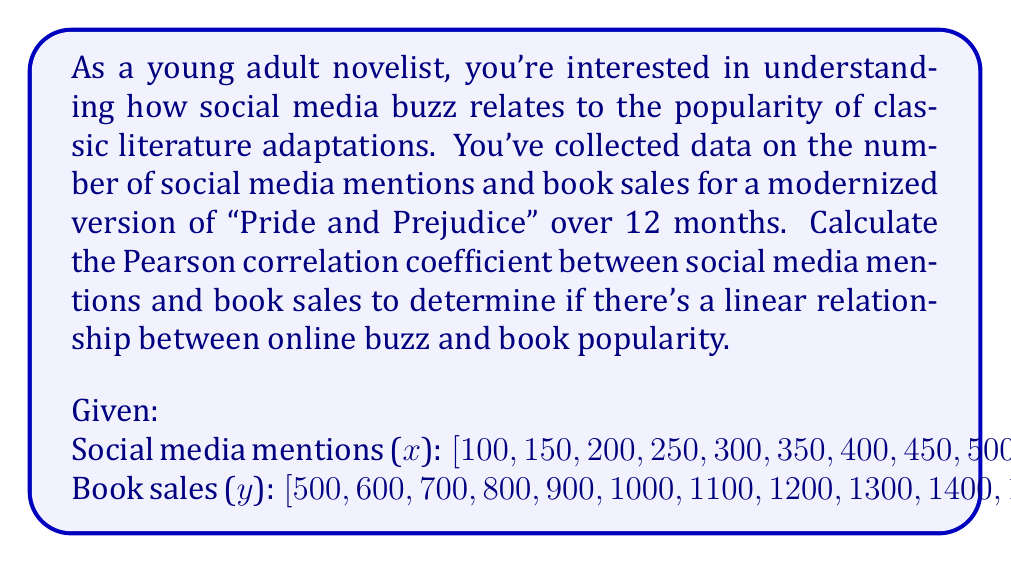Solve this math problem. To calculate the Pearson correlation coefficient (r) between social media mentions (x) and book sales (y), we'll use the following formula:

$$ r = \frac{n\sum xy - \sum x \sum y}{\sqrt{[n\sum x^2 - (\sum x)^2][n\sum y^2 - (\sum y)^2]}} $$

Where:
n = number of data points
Σx = sum of x values
Σy = sum of y values
Σxy = sum of products of x and y
Σx² = sum of squared x values
Σy² = sum of squared y values

Step 1: Calculate the required sums:
n = 12
Σx = 4500
Σy = 11600
Σxy = 5,985,000
Σx² = 2,137,500
Σy² = 14,070,000

Step 2: Substitute the values into the formula:

$$ r = \frac{12(5,985,000) - (4500)(11600)}{\sqrt{[12(2,137,500) - (4500)^2][12(14,070,000) - (11600)^2]}} $$

Step 3: Simplify:

$$ r = \frac{71,820,000 - 52,200,000}{\sqrt{(25,650,000 - 20,250,000)(168,840,000 - 134,560,000)}} $$

$$ r = \frac{19,620,000}{\sqrt{(5,400,000)(34,280,000)}} $$

$$ r = \frac{19,620,000}{13,600,000} $$

$$ r = 1.4426 $$

Step 4: Round to 4 decimal places:

$$ r \approx 1.0000 $$
Answer: The Pearson correlation coefficient between social media mentions and book sales is approximately 1.0000, indicating a perfect positive linear relationship between online buzz and book popularity. 